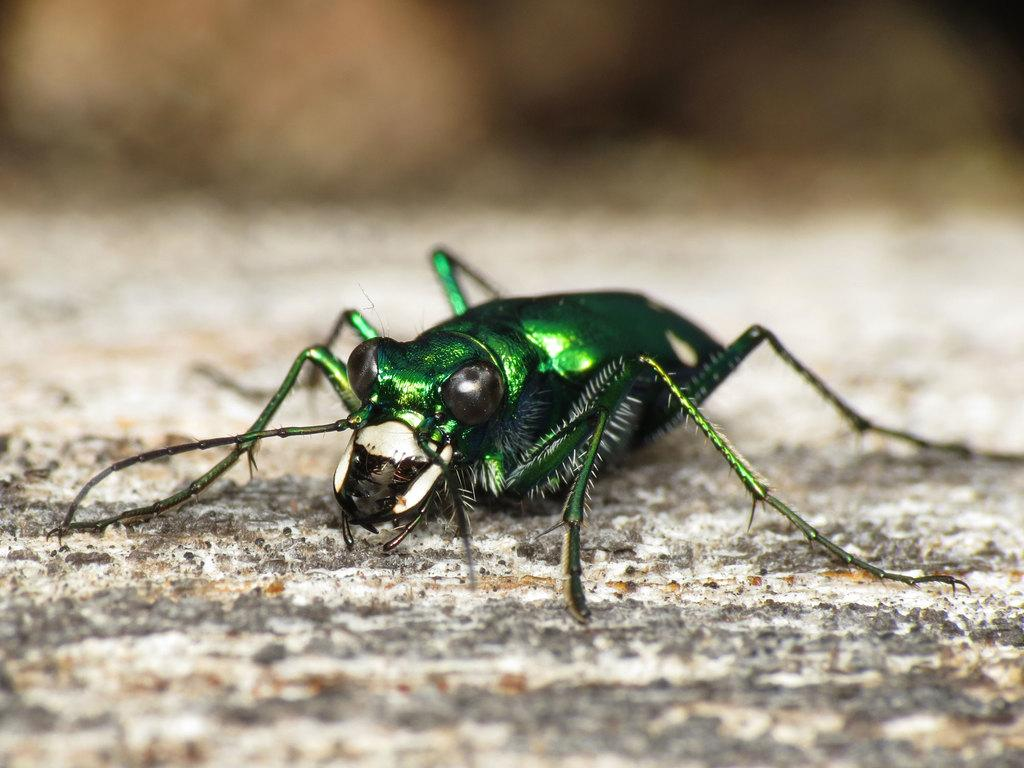What type of creature can be seen in the image? There is an insect in the image. Where is the insect located? The insect is on the ground. Can you describe the background of the image? The background of the image is blurred. How many kittens can be seen playing in the ocean in the image? There are no kittens or ocean present in the image; it features an insect on the ground with a blurred background. 